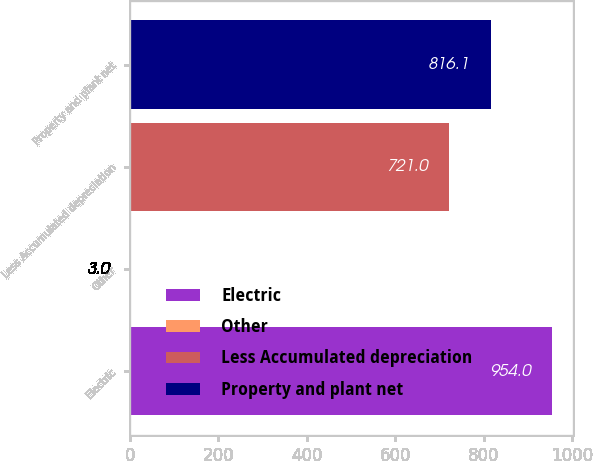Convert chart to OTSL. <chart><loc_0><loc_0><loc_500><loc_500><bar_chart><fcel>Electric<fcel>Other<fcel>Less Accumulated depreciation<fcel>Property and plant net<nl><fcel>954<fcel>3<fcel>721<fcel>816.1<nl></chart> 